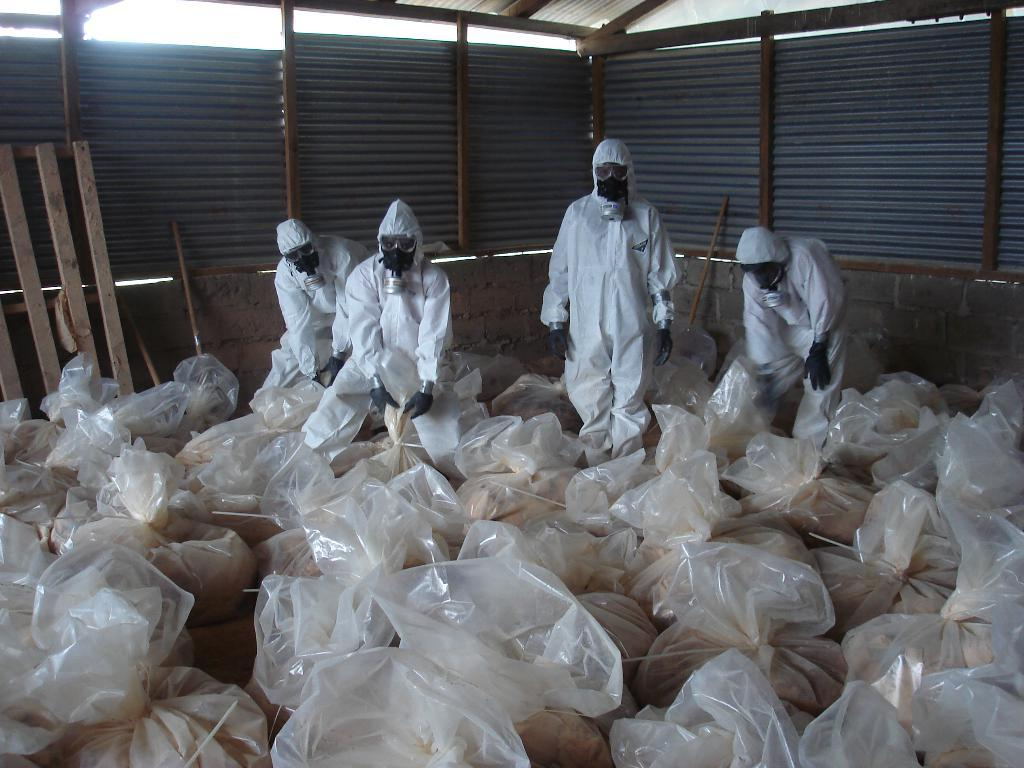What are the people in the image wearing? The people in the image are wearing white costumes. What can be seen on the ground in the image? There are plastic bags on the ground in the image. What type of structure is present in the image? There is a tin shed in the image. What type of stove is visible in the image? There is no stove present in the image. How many legs does the tin shed have in the image? The tin shed in the image does not have legs; it is a structure resting on the ground. 